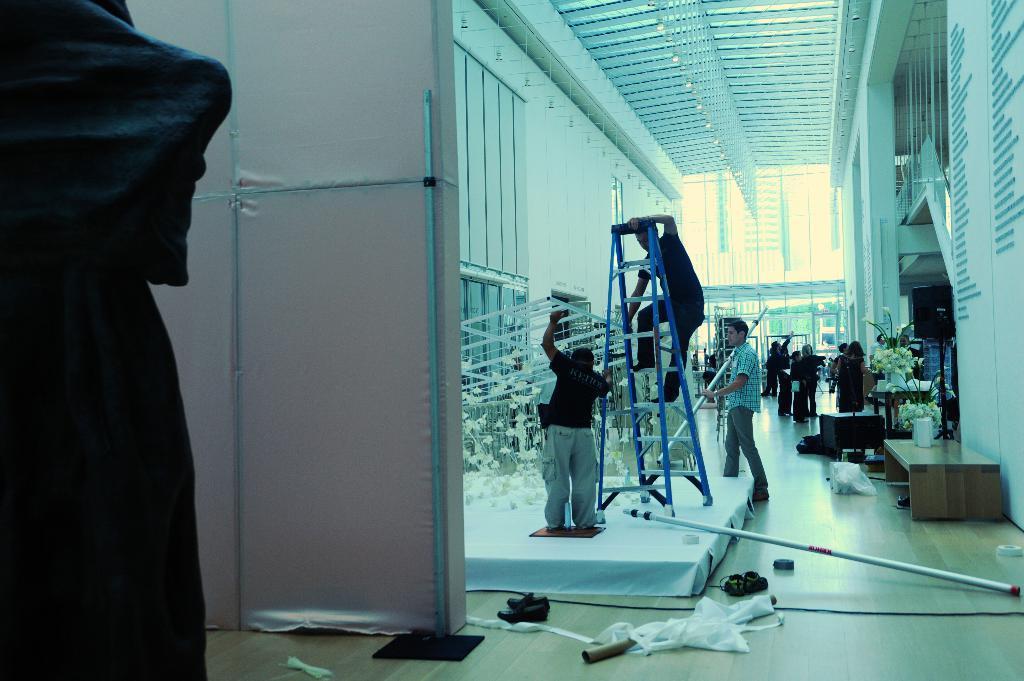How would you summarize this image in a sentence or two? In this image I see the inside view of a building and I see the wall, ceiling, number of people, few flowers over here and I see few equipment and I see the floor. 